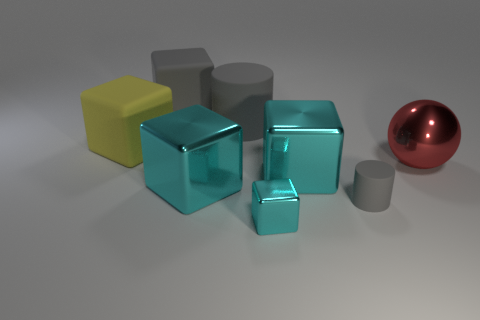How many large cylinders have the same color as the small cylinder?
Your answer should be compact. 1. Does the big matte cylinder have the same color as the matte cube that is on the right side of the big yellow object?
Your response must be concise. Yes. There is a cube that is the same color as the large rubber cylinder; what is its size?
Provide a short and direct response. Large. Is there anything else that is the same color as the tiny block?
Provide a short and direct response. Yes. What material is the yellow thing that is in front of the gray rubber cylinder that is behind the cylinder that is in front of the red metal ball?
Provide a succinct answer. Rubber. What number of shiny things are either spheres or big cubes?
Give a very brief answer. 3. How many blue objects are large matte cylinders or blocks?
Offer a terse response. 0. There is a big cube behind the yellow thing; is its color the same as the large matte cylinder?
Provide a short and direct response. Yes. Is the material of the sphere the same as the tiny gray thing?
Make the answer very short. No. Is the number of cylinders that are behind the tiny gray rubber thing the same as the number of gray things that are right of the tiny cyan object?
Keep it short and to the point. Yes. 